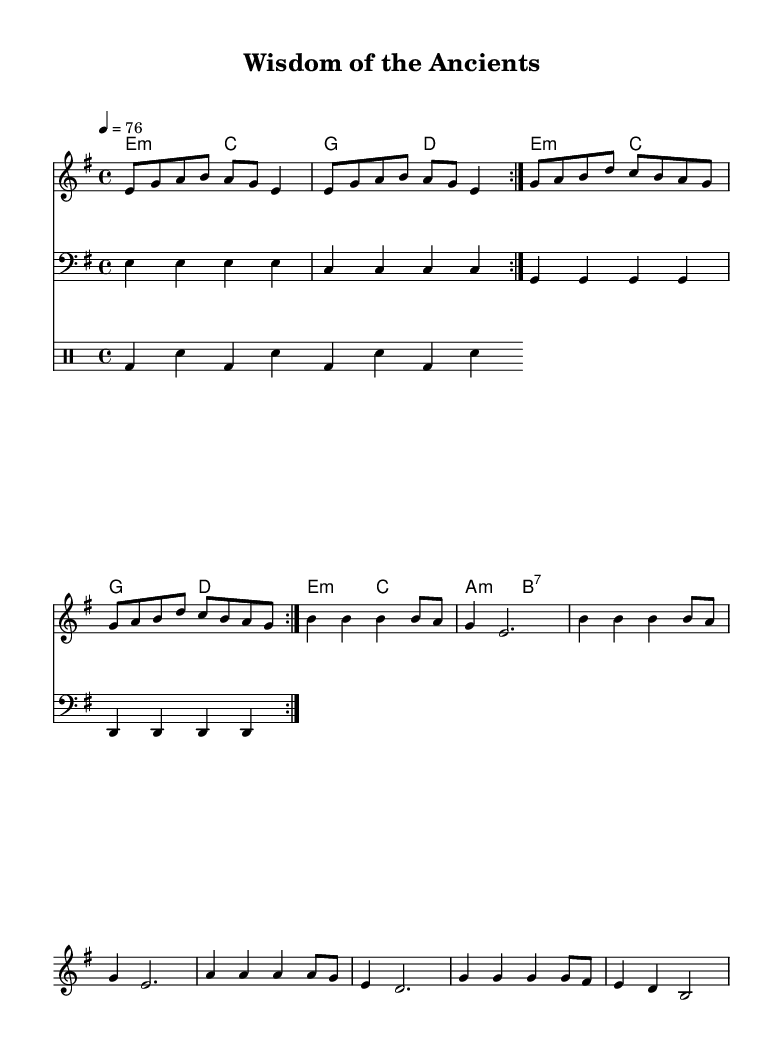What is the key signature of this music? The key signature is indicated by the placement of sharps or flats. In this score, it shows an 'E minor' key signature, noted by the absence of any sharps or flats.
Answer: E minor What is the time signature of this piece? The time signature is located at the beginning of the score and indicates the rhythm structure. Here it is marked as '4/4', meaning there are four beats in each measure.
Answer: 4/4 What is the tempo marking for this piece? The tempo marking is given near the beginning of the piece. It shows a speed of '76', indicating the beats per minute to follow for playing.
Answer: 76 How many repetitions does the melody phrase have? The score indicates that the melody should be repeated, which is shown with the text 'volta 2', meaning the section is to be played two times.
Answer: 2 What type of chords are predominantly used in this piece? By reviewing the chord names section, it can be seen that the chords include 'minor' and 'major' types, indicating a common practice in reggae to incorporate these harmonies.
Answer: minor What is the theme of the verse one lyrics? The lyrics begin with "Diggin' through the sands of time," suggesting a focus on exploring and discovering ancient knowledge. Thus, the theme is about searching for wisdom from the past.
Answer: ancient wisdom How does this piece reflect the reggae style in its rhythm? Analyzing the drum patterns, typical reggae features such as off-beat rhythms are clear, particularly prominent in the bass drum and snare accents, creating a laid-back groove characteristic of reggae music.
Answer: off-beat rhythm 